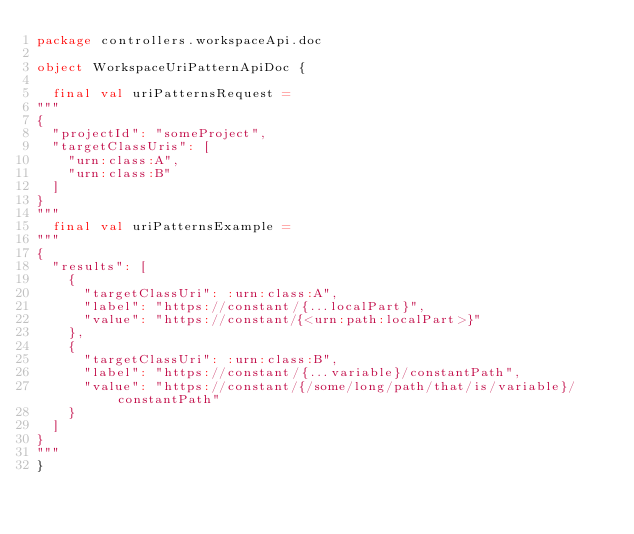<code> <loc_0><loc_0><loc_500><loc_500><_Scala_>package controllers.workspaceApi.doc

object WorkspaceUriPatternApiDoc {

  final val uriPatternsRequest =
"""
{
  "projectId": "someProject",
  "targetClassUris": [
    "urn:class:A",
    "urn:class:B"
  ]
}
"""
  final val uriPatternsExample =
"""
{
  "results": [
    {
      "targetClassUri": :urn:class:A",
      "label": "https://constant/{...localPart}",
      "value": "https://constant/{<urn:path:localPart>}"
    },
    {
      "targetClassUri": :urn:class:B",
      "label": "https://constant/{...variable}/constantPath",
      "value": "https://constant/{/some/long/path/that/is/variable}/constantPath"
    }
  ]
}
"""
}
</code> 